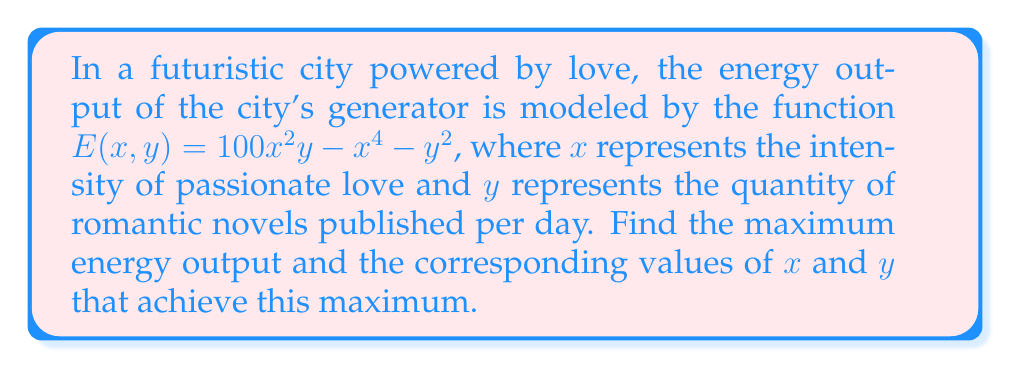Show me your answer to this math problem. To find the maximum energy output, we need to find the critical points of the function $E(x, y)$ and evaluate them. Let's follow these steps:

1. Find the partial derivatives of $E(x, y)$ with respect to $x$ and $y$:

   $$\frac{\partial E}{\partial x} = 200xy - 4x^3$$
   $$\frac{\partial E}{\partial y} = 100x^2 - 2y$$

2. Set both partial derivatives to zero and solve the resulting system of equations:

   $$200xy - 4x^3 = 0$$
   $$100x^2 - 2y = 0$$

3. From the second equation, we can express $y$ in terms of $x$:

   $$y = 50x^2$$

4. Substitute this into the first equation:

   $$200x(50x^2) - 4x^3 = 0$$
   $$10000x^3 - 4x^3 = 0$$
   $$9996x^3 = 0$$

5. Solve for $x$:

   $$x = 0$$ or $$x = \pm\sqrt{\frac{50}{3}}$$

6. When $x = 0$, $y = 0$, which gives $E(0, 0) = 0$.

7. For $x = \pm\sqrt{\frac{50}{3}}$, calculate the corresponding $y$ and $E$ values:

   $$y = 50(\frac{50}{3}) = \frac{2500}{3}$$
   
   $$E(\pm\sqrt{\frac{50}{3}}, \frac{2500}{3}) = 100(\frac{50}{3})(\frac{2500}{3}) - (\frac{50}{3})^2 - (\frac{2500}{3})^2$$
   $$= \frac{12500000}{9} - \frac{2500}{9} - \frac{6250000}{9} = \frac{6247500}{9}$$

8. Compare the values of $E$ at the critical points to determine the maximum:

   $E(0, 0) = 0$
   $E(\pm\sqrt{\frac{50}{3}}, \frac{2500}{3}) = \frac{6247500}{9}$

The maximum value occurs at $x = \pm\sqrt{\frac{50}{3}}$ and $y = \frac{2500}{3}$.
Answer: The maximum energy output is $\frac{6247500}{9} \approx 694166.67$ units. This occurs when the intensity of passionate love is $x = \pm\sqrt{\frac{50}{3}} \approx \pm4.08$ and the quantity of romantic novels published per day is $y = \frac{2500}{3} \approx 833.33$. 